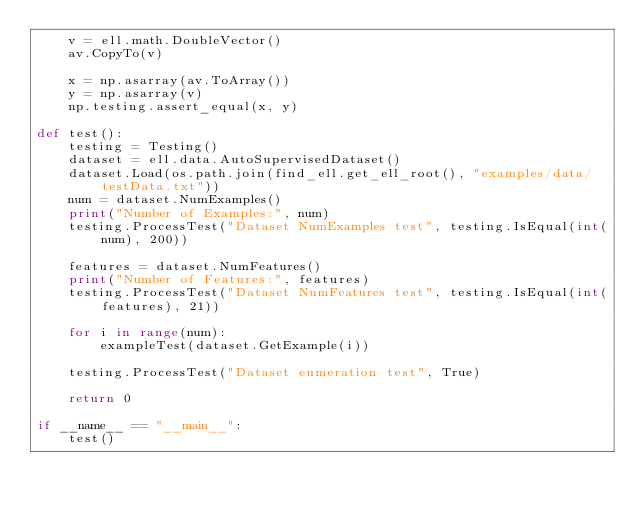Convert code to text. <code><loc_0><loc_0><loc_500><loc_500><_Python_>    v = ell.math.DoubleVector()
    av.CopyTo(v)

    x = np.asarray(av.ToArray())
    y = np.asarray(v)
    np.testing.assert_equal(x, y)

def test():
    testing = Testing()
    dataset = ell.data.AutoSupervisedDataset()
    dataset.Load(os.path.join(find_ell.get_ell_root(), "examples/data/testData.txt"))
    num = dataset.NumExamples()
    print("Number of Examples:", num)
    testing.ProcessTest("Dataset NumExamples test", testing.IsEqual(int(num), 200))

    features = dataset.NumFeatures()
    print("Number of Features:", features)
    testing.ProcessTest("Dataset NumFeatures test", testing.IsEqual(int(features), 21))

    for i in range(num):
        exampleTest(dataset.GetExample(i))

    testing.ProcessTest("Dataset eumeration test", True)

    return 0

if __name__ == "__main__":
    test()
</code> 